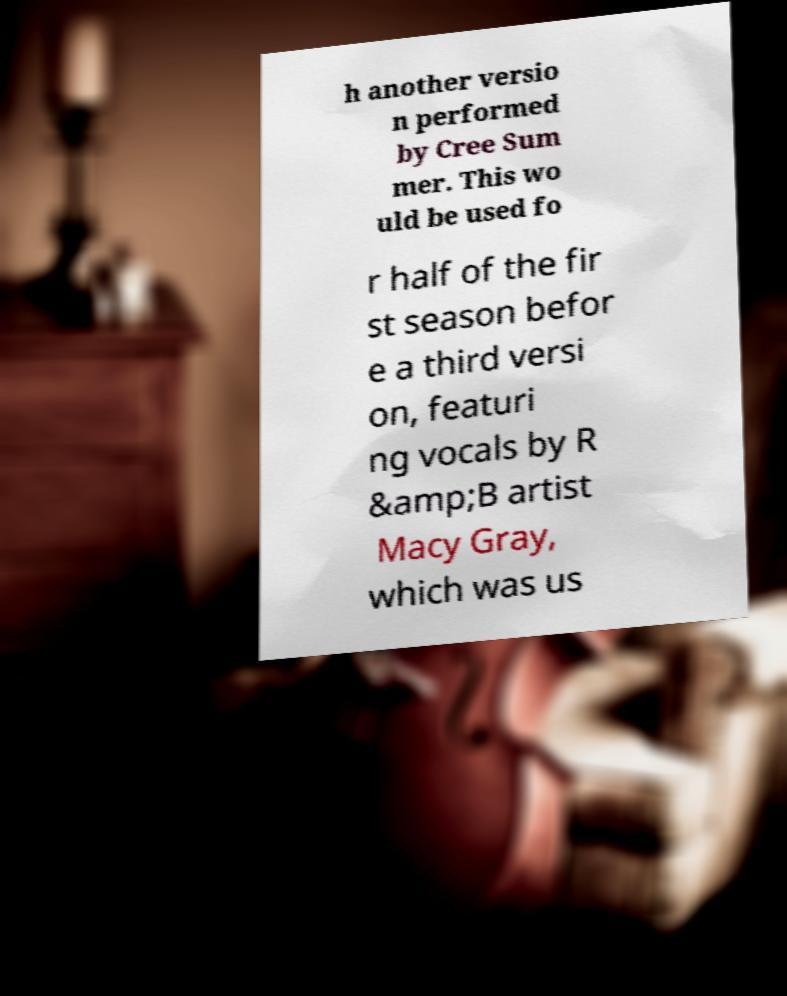What messages or text are displayed in this image? I need them in a readable, typed format. h another versio n performed by Cree Sum mer. This wo uld be used fo r half of the fir st season befor e a third versi on, featuri ng vocals by R &amp;B artist Macy Gray, which was us 